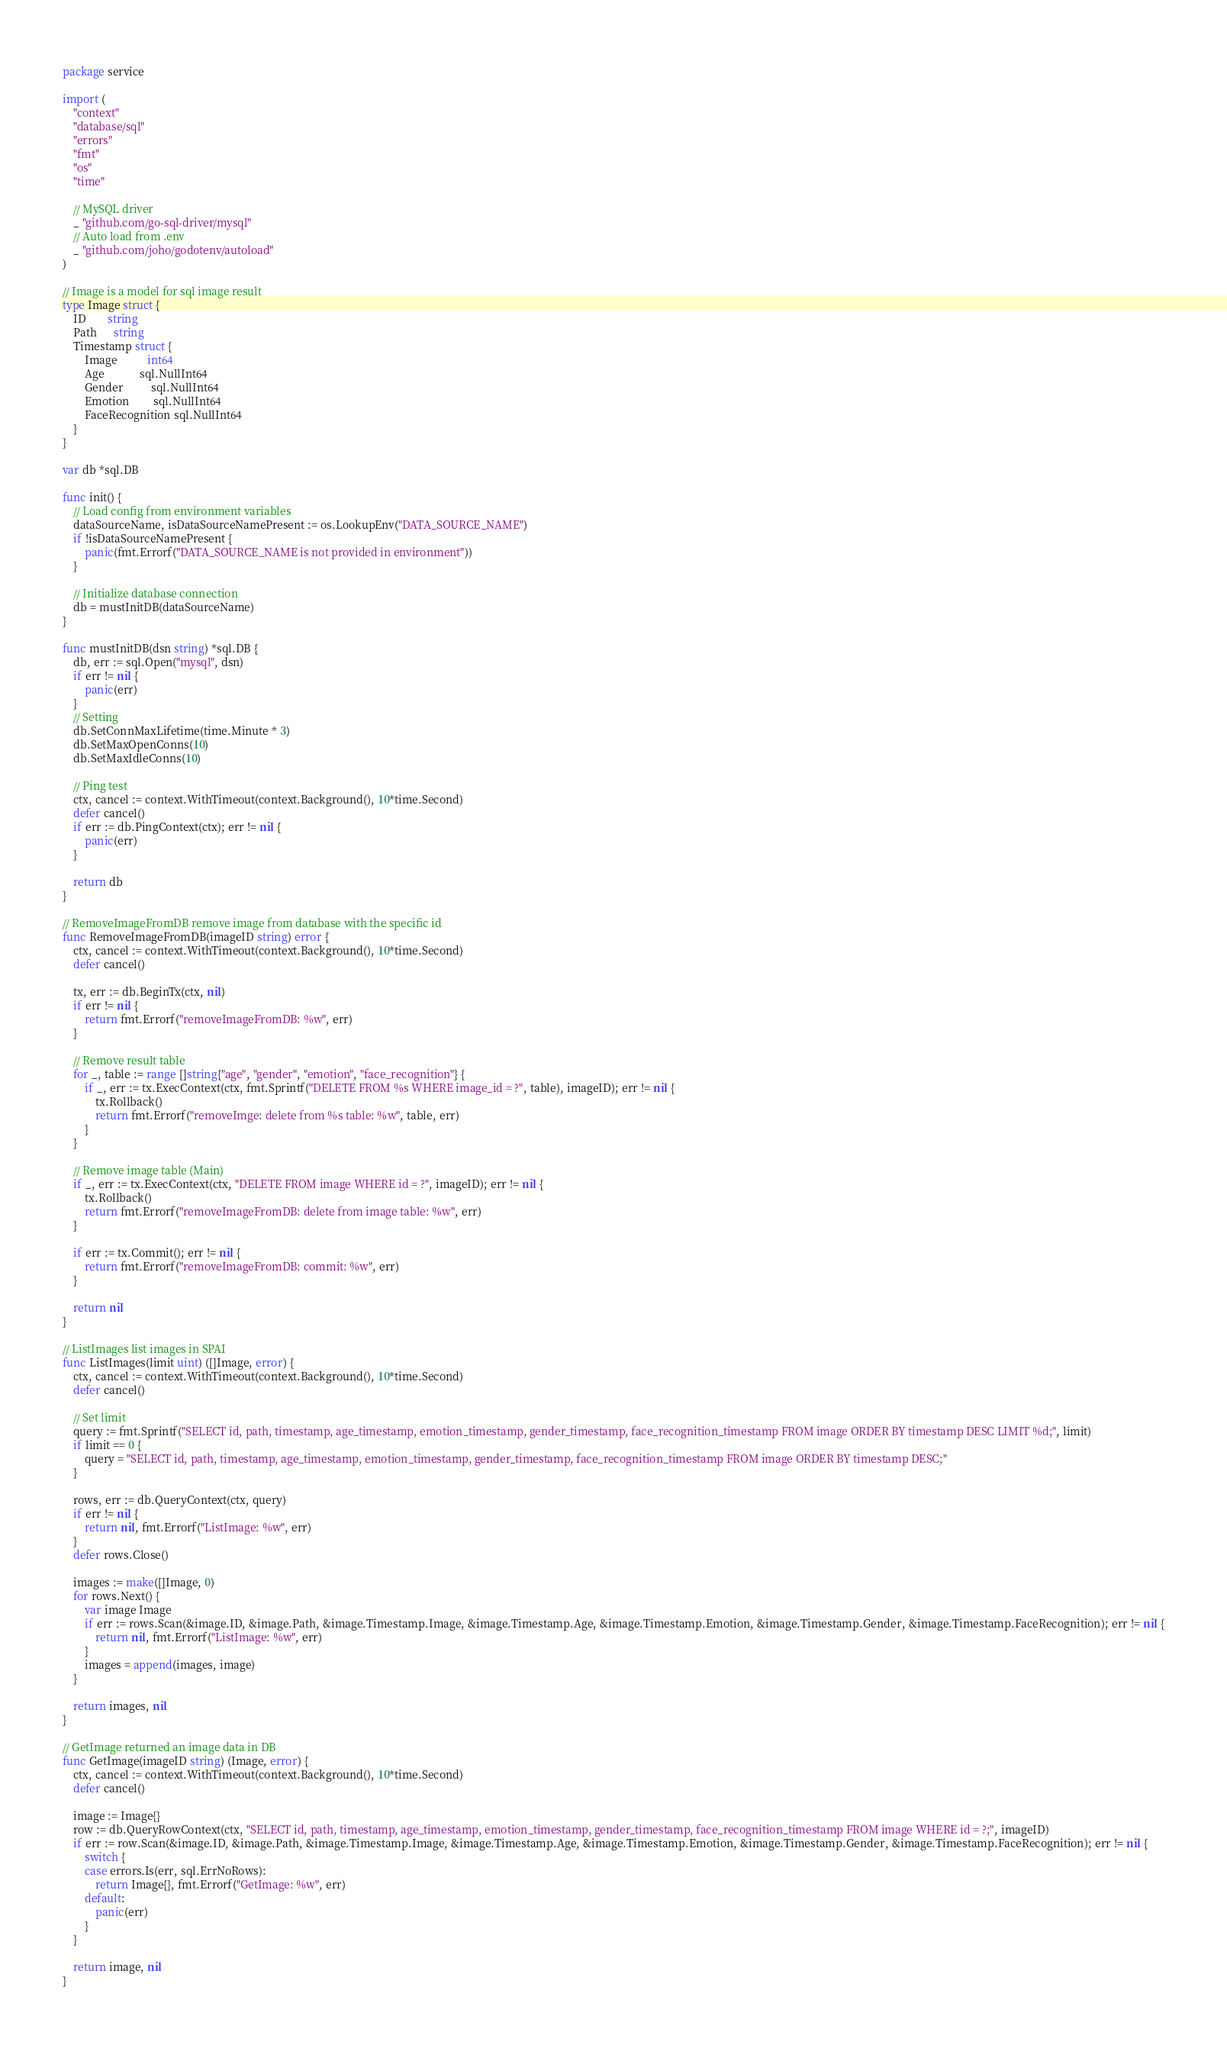<code> <loc_0><loc_0><loc_500><loc_500><_Go_>package service

import (
	"context"
	"database/sql"
	"errors"
	"fmt"
	"os"
	"time"

	// MySQL driver
	_ "github.com/go-sql-driver/mysql"
	// Auto load from .env
	_ "github.com/joho/godotenv/autoload"
)

// Image is a model for sql image result
type Image struct {
	ID        string
	Path      string
	Timestamp struct {
		Image           int64
		Age             sql.NullInt64
		Gender          sql.NullInt64
		Emotion         sql.NullInt64
		FaceRecognition sql.NullInt64
	}
}

var db *sql.DB

func init() {
	// Load config from environment variables
	dataSourceName, isDataSourceNamePresent := os.LookupEnv("DATA_SOURCE_NAME")
	if !isDataSourceNamePresent {
		panic(fmt.Errorf("DATA_SOURCE_NAME is not provided in environment"))
	}

	// Initialize database connection
	db = mustInitDB(dataSourceName)
}

func mustInitDB(dsn string) *sql.DB {
	db, err := sql.Open("mysql", dsn)
	if err != nil {
		panic(err)
	}
	// Setting
	db.SetConnMaxLifetime(time.Minute * 3)
	db.SetMaxOpenConns(10)
	db.SetMaxIdleConns(10)

	// Ping test
	ctx, cancel := context.WithTimeout(context.Background(), 10*time.Second)
	defer cancel()
	if err := db.PingContext(ctx); err != nil {
		panic(err)
	}

	return db
}

// RemoveImageFromDB remove image from database with the specific id
func RemoveImageFromDB(imageID string) error {
	ctx, cancel := context.WithTimeout(context.Background(), 10*time.Second)
	defer cancel()

	tx, err := db.BeginTx(ctx, nil)
	if err != nil {
		return fmt.Errorf("removeImageFromDB: %w", err)
	}

	// Remove result table
	for _, table := range []string{"age", "gender", "emotion", "face_recognition"} {
		if _, err := tx.ExecContext(ctx, fmt.Sprintf("DELETE FROM %s WHERE image_id = ?", table), imageID); err != nil {
			tx.Rollback()
			return fmt.Errorf("removeImge: delete from %s table: %w", table, err)
		}
	}

	// Remove image table (Main)
	if _, err := tx.ExecContext(ctx, "DELETE FROM image WHERE id = ?", imageID); err != nil {
		tx.Rollback()
		return fmt.Errorf("removeImageFromDB: delete from image table: %w", err)
	}

	if err := tx.Commit(); err != nil {
		return fmt.Errorf("removeImageFromDB: commit: %w", err)
	}

	return nil
}

// ListImages list images in SPAI
func ListImages(limit uint) ([]Image, error) {
	ctx, cancel := context.WithTimeout(context.Background(), 10*time.Second)
	defer cancel()

	// Set limit
	query := fmt.Sprintf("SELECT id, path, timestamp, age_timestamp, emotion_timestamp, gender_timestamp, face_recognition_timestamp FROM image ORDER BY timestamp DESC LIMIT %d;", limit)
	if limit == 0 {
		query = "SELECT id, path, timestamp, age_timestamp, emotion_timestamp, gender_timestamp, face_recognition_timestamp FROM image ORDER BY timestamp DESC;"
	}

	rows, err := db.QueryContext(ctx, query)
	if err != nil {
		return nil, fmt.Errorf("ListImage: %w", err)
	}
	defer rows.Close()

	images := make([]Image, 0)
	for rows.Next() {
		var image Image
		if err := rows.Scan(&image.ID, &image.Path, &image.Timestamp.Image, &image.Timestamp.Age, &image.Timestamp.Emotion, &image.Timestamp.Gender, &image.Timestamp.FaceRecognition); err != nil {
			return nil, fmt.Errorf("ListImage: %w", err)
		}
		images = append(images, image)
	}

	return images, nil
}

// GetImage returned an image data in DB
func GetImage(imageID string) (Image, error) {
	ctx, cancel := context.WithTimeout(context.Background(), 10*time.Second)
	defer cancel()

	image := Image{}
	row := db.QueryRowContext(ctx, "SELECT id, path, timestamp, age_timestamp, emotion_timestamp, gender_timestamp, face_recognition_timestamp FROM image WHERE id = ?;", imageID)
	if err := row.Scan(&image.ID, &image.Path, &image.Timestamp.Image, &image.Timestamp.Age, &image.Timestamp.Emotion, &image.Timestamp.Gender, &image.Timestamp.FaceRecognition); err != nil {
		switch {
		case errors.Is(err, sql.ErrNoRows):
			return Image{}, fmt.Errorf("GetImage: %w", err)
		default:
			panic(err)
		}
	}

	return image, nil
}
</code> 